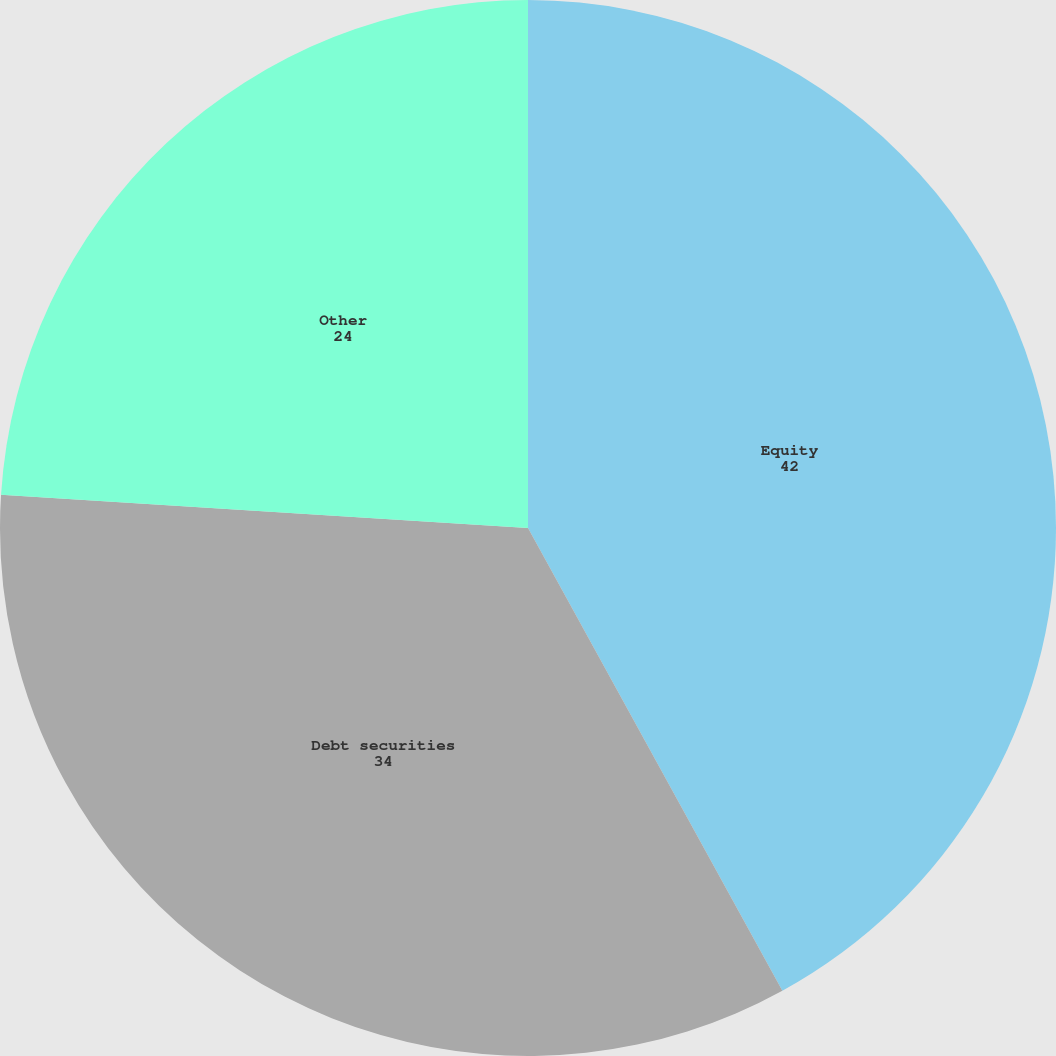<chart> <loc_0><loc_0><loc_500><loc_500><pie_chart><fcel>Equity<fcel>Debt securities<fcel>Other<nl><fcel>42.0%<fcel>34.0%<fcel>24.0%<nl></chart> 